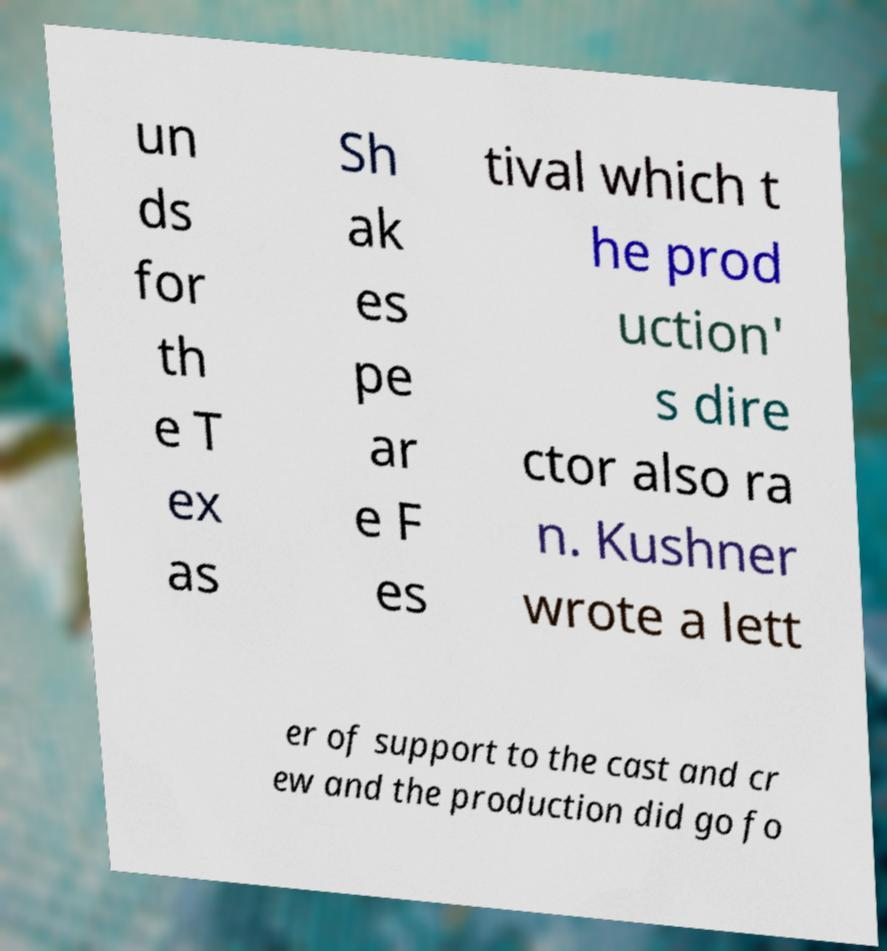Please identify and transcribe the text found in this image. un ds for th e T ex as Sh ak es pe ar e F es tival which t he prod uction' s dire ctor also ra n. Kushner wrote a lett er of support to the cast and cr ew and the production did go fo 